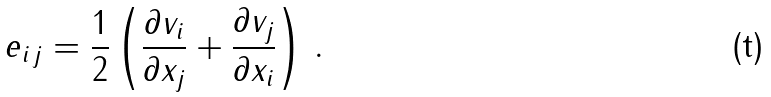Convert formula to latex. <formula><loc_0><loc_0><loc_500><loc_500>e _ { i \, j } = \frac { 1 } { 2 } \left ( \frac { \partial v _ { i } } { \partial x _ { j } } + \frac { \partial v _ { j } } { \partial x _ { i } } \right ) \, .</formula> 